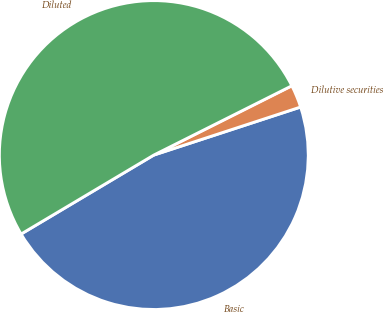<chart> <loc_0><loc_0><loc_500><loc_500><pie_chart><fcel>Basic<fcel>Dilutive securities<fcel>Diluted<nl><fcel>46.49%<fcel>2.37%<fcel>51.14%<nl></chart> 